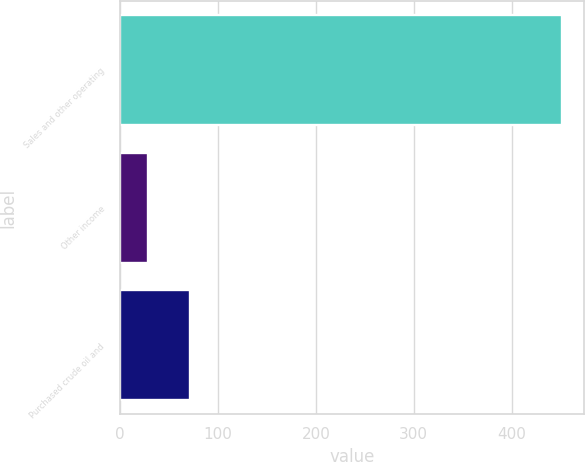Convert chart. <chart><loc_0><loc_0><loc_500><loc_500><bar_chart><fcel>Sales and other operating<fcel>Other income<fcel>Purchased crude oil and<nl><fcel>451<fcel>29<fcel>71.2<nl></chart> 